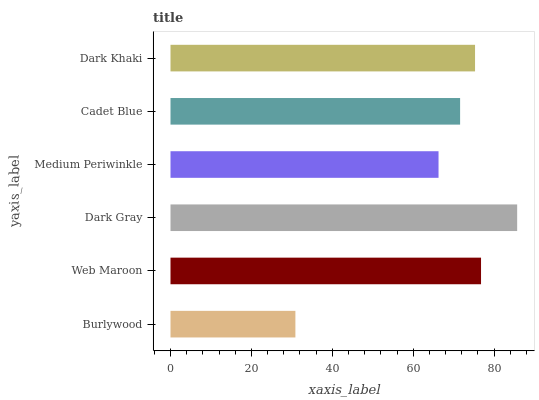Is Burlywood the minimum?
Answer yes or no. Yes. Is Dark Gray the maximum?
Answer yes or no. Yes. Is Web Maroon the minimum?
Answer yes or no. No. Is Web Maroon the maximum?
Answer yes or no. No. Is Web Maroon greater than Burlywood?
Answer yes or no. Yes. Is Burlywood less than Web Maroon?
Answer yes or no. Yes. Is Burlywood greater than Web Maroon?
Answer yes or no. No. Is Web Maroon less than Burlywood?
Answer yes or no. No. Is Dark Khaki the high median?
Answer yes or no. Yes. Is Cadet Blue the low median?
Answer yes or no. Yes. Is Web Maroon the high median?
Answer yes or no. No. Is Dark Khaki the low median?
Answer yes or no. No. 